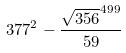Convert formula to latex. <formula><loc_0><loc_0><loc_500><loc_500>3 7 7 ^ { 2 } - \frac { \sqrt { 3 5 6 } ^ { 4 9 9 } } { 5 9 }</formula> 